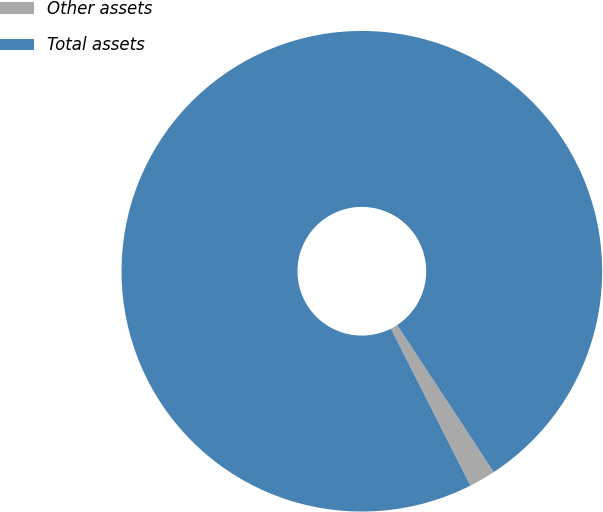<chart> <loc_0><loc_0><loc_500><loc_500><pie_chart><fcel>Other assets<fcel>Total assets<nl><fcel>1.79%<fcel>98.21%<nl></chart> 